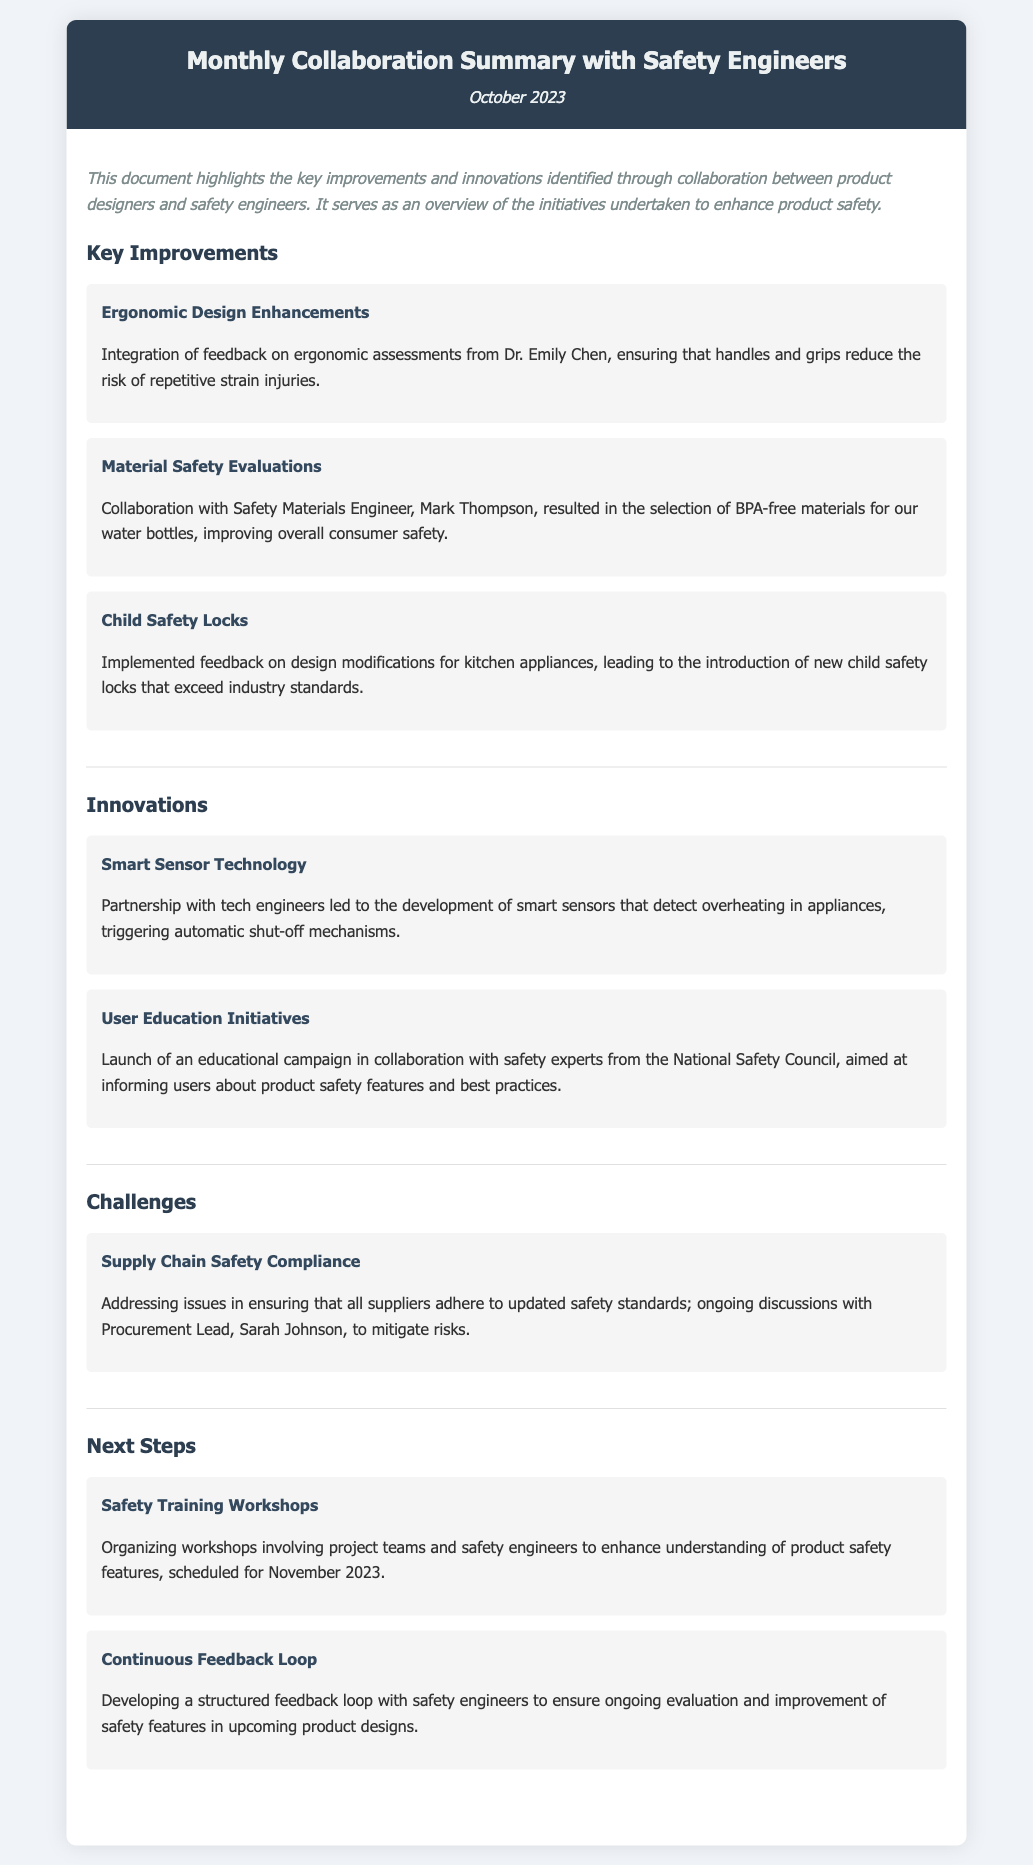What is the main purpose of the document? The document serves as an overview of the initiatives undertaken to enhance product safety through collaboration between product designers and safety engineers.
Answer: Overview of initiatives to enhance product safety Who provided feedback on ergonomic assessments? Dr. Emily Chen contributed feedback specifically regarding ergonomic assessments to improve designs.
Answer: Dr. Emily Chen What type of technology was developed in collaboration with tech engineers? The document mentions the development of smart sensors that detect overheating in appliances.
Answer: Smart Sensor Technology When are the safety training workshops scheduled? The timing for the safety training workshops is specified as November 2023.
Answer: November 2023 What new feature was introduced for kitchen appliances? The document highlights the introduction of new child safety locks that exceed industry standards.
Answer: Child safety locks Which material was selected for water bottles? BPA-free materials were chosen based on collaborative evaluations to improve consumer safety.
Answer: BPA-free materials What challenge is outlined regarding safety compliance? The document indicates that there are ongoing discussions about ensuring all suppliers adhere to updated safety standards.
Answer: Supply Chain Safety Compliance What initiative aims to inform users about product safety? The document mentions an educational campaign launched in collaboration with the National Safety Council.
Answer: User Education Initiatives What is the next step involving safety engineers? A structured feedback loop with safety engineers is being developed for ongoing evaluation and improvement of safety features.
Answer: Continuous Feedback Loop 